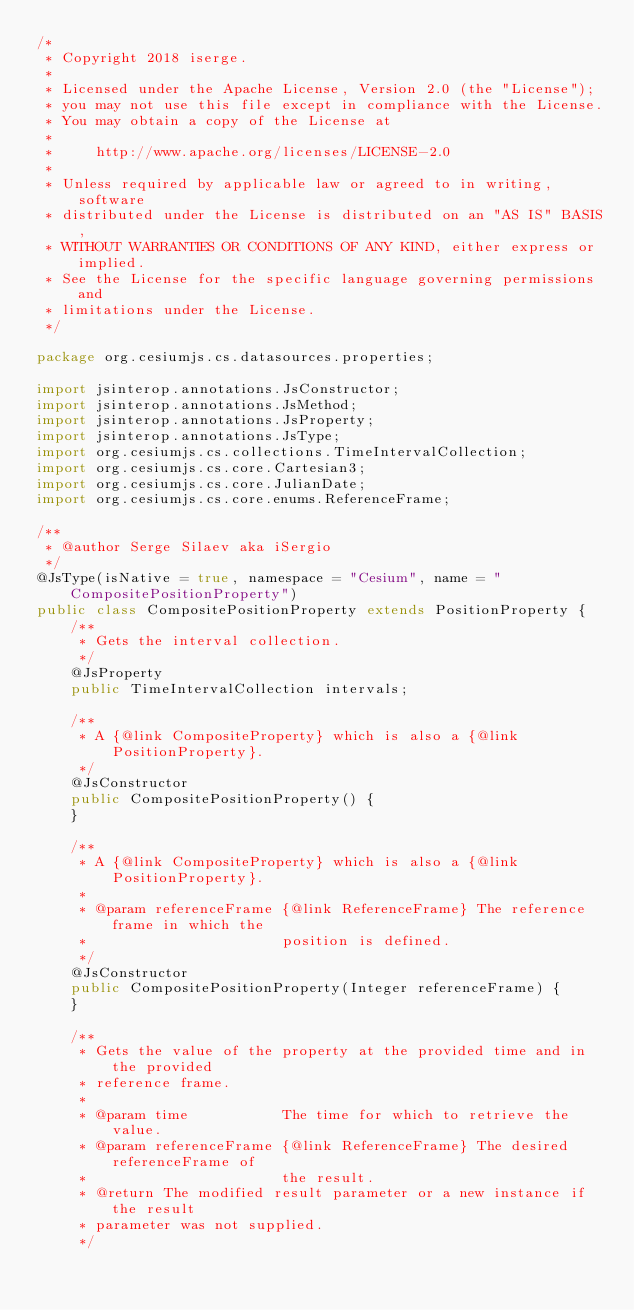<code> <loc_0><loc_0><loc_500><loc_500><_Java_>/*
 * Copyright 2018 iserge.
 *
 * Licensed under the Apache License, Version 2.0 (the "License");
 * you may not use this file except in compliance with the License.
 * You may obtain a copy of the License at
 *
 *     http://www.apache.org/licenses/LICENSE-2.0
 *
 * Unless required by applicable law or agreed to in writing, software
 * distributed under the License is distributed on an "AS IS" BASIS,
 * WITHOUT WARRANTIES OR CONDITIONS OF ANY KIND, either express or implied.
 * See the License for the specific language governing permissions and
 * limitations under the License.
 */

package org.cesiumjs.cs.datasources.properties;

import jsinterop.annotations.JsConstructor;
import jsinterop.annotations.JsMethod;
import jsinterop.annotations.JsProperty;
import jsinterop.annotations.JsType;
import org.cesiumjs.cs.collections.TimeIntervalCollection;
import org.cesiumjs.cs.core.Cartesian3;
import org.cesiumjs.cs.core.JulianDate;
import org.cesiumjs.cs.core.enums.ReferenceFrame;

/**
 * @author Serge Silaev aka iSergio
 */
@JsType(isNative = true, namespace = "Cesium", name = "CompositePositionProperty")
public class CompositePositionProperty extends PositionProperty {
    /**
     * Gets the interval collection.
     */
    @JsProperty
    public TimeIntervalCollection intervals;

    /**
     * A {@link CompositeProperty} which is also a {@link PositionProperty}.
     */
    @JsConstructor
    public CompositePositionProperty() {
    }

    /**
     * A {@link CompositeProperty} which is also a {@link PositionProperty}.
     *
     * @param referenceFrame {@link ReferenceFrame} The reference frame in which the
     *                       position is defined.
     */
    @JsConstructor
    public CompositePositionProperty(Integer referenceFrame) {
    }

    /**
     * Gets the value of the property at the provided time and in the provided
     * reference frame.
     *
     * @param time           The time for which to retrieve the value.
     * @param referenceFrame {@link ReferenceFrame} The desired referenceFrame of
     *                       the result.
     * @return The modified result parameter or a new instance if the result
     * parameter was not supplied.
     */</code> 